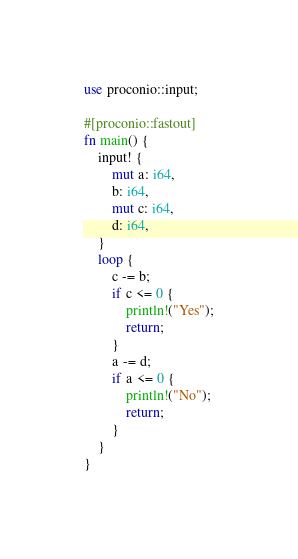<code> <loc_0><loc_0><loc_500><loc_500><_Rust_>use proconio::input;

#[proconio::fastout]
fn main() {
    input! {
        mut a: i64,
        b: i64,
        mut c: i64,
        d: i64,
    }
    loop {
        c -= b;
        if c <= 0 {
            println!("Yes");
            return;
        }
        a -= d;
        if a <= 0 {
            println!("No");
            return;
        }
    }
}
</code> 